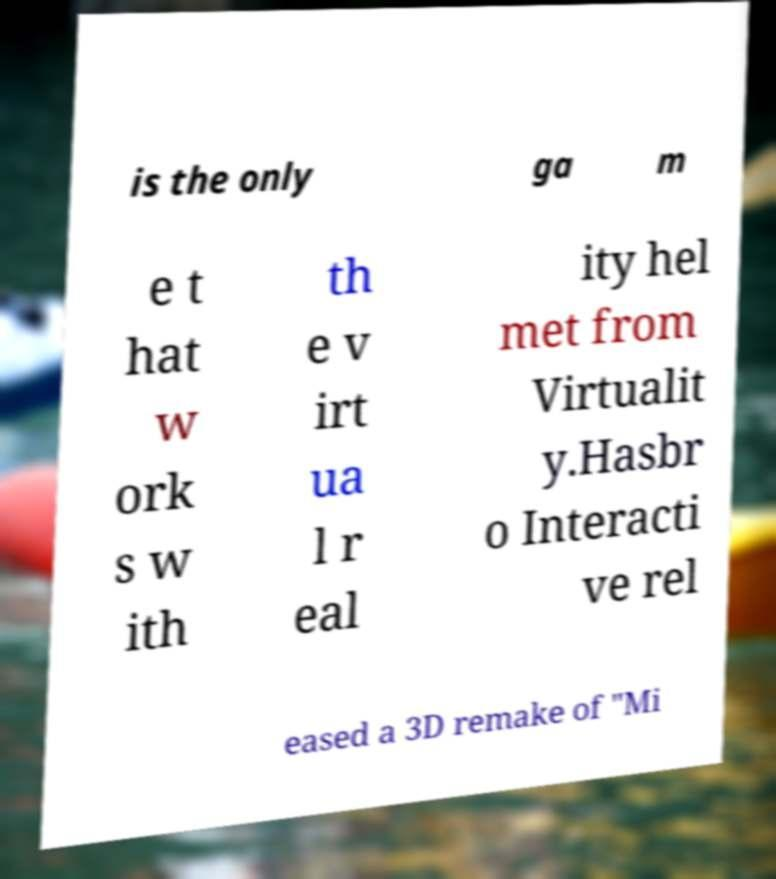What messages or text are displayed in this image? I need them in a readable, typed format. is the only ga m e t hat w ork s w ith th e v irt ua l r eal ity hel met from Virtualit y.Hasbr o Interacti ve rel eased a 3D remake of "Mi 